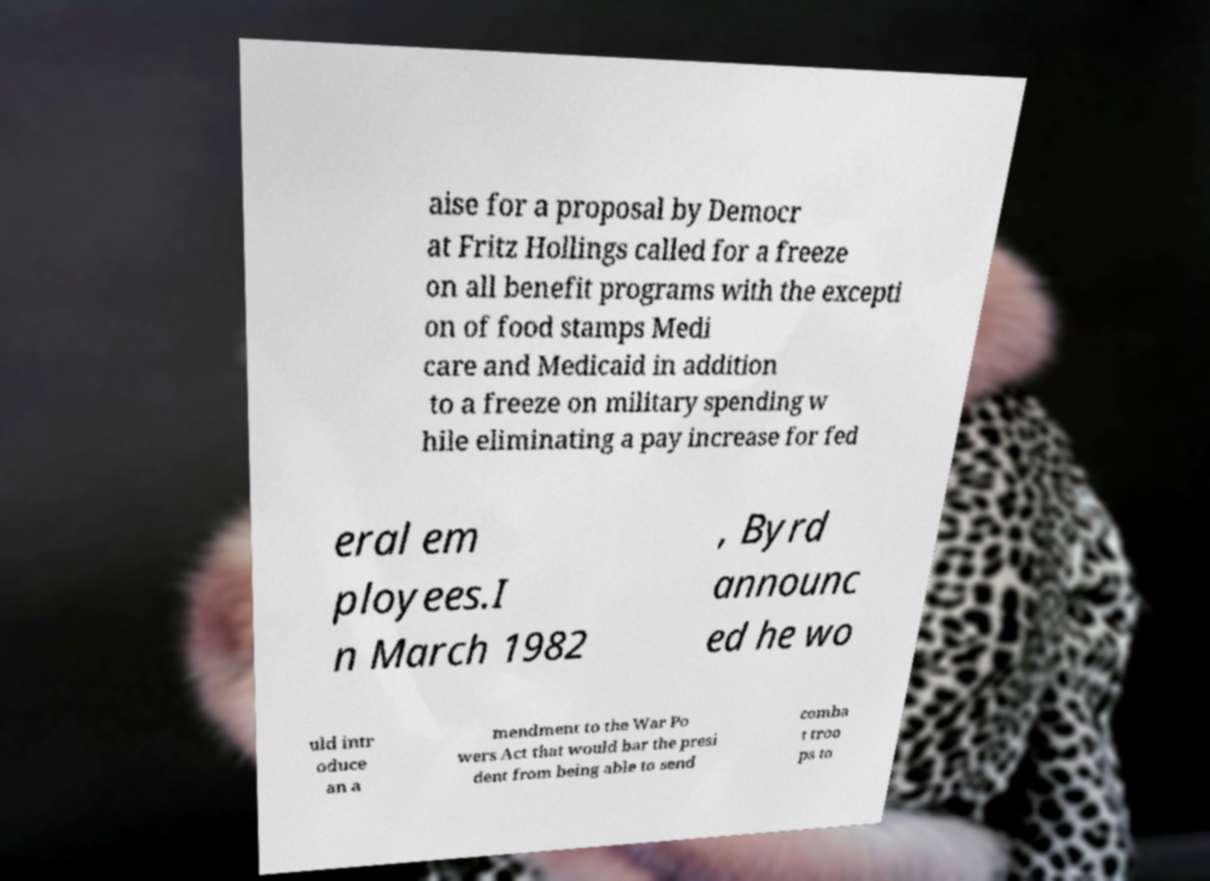Could you assist in decoding the text presented in this image and type it out clearly? aise for a proposal by Democr at Fritz Hollings called for a freeze on all benefit programs with the excepti on of food stamps Medi care and Medicaid in addition to a freeze on military spending w hile eliminating a pay increase for fed eral em ployees.I n March 1982 , Byrd announc ed he wo uld intr oduce an a mendment to the War Po wers Act that would bar the presi dent from being able to send comba t troo ps to 